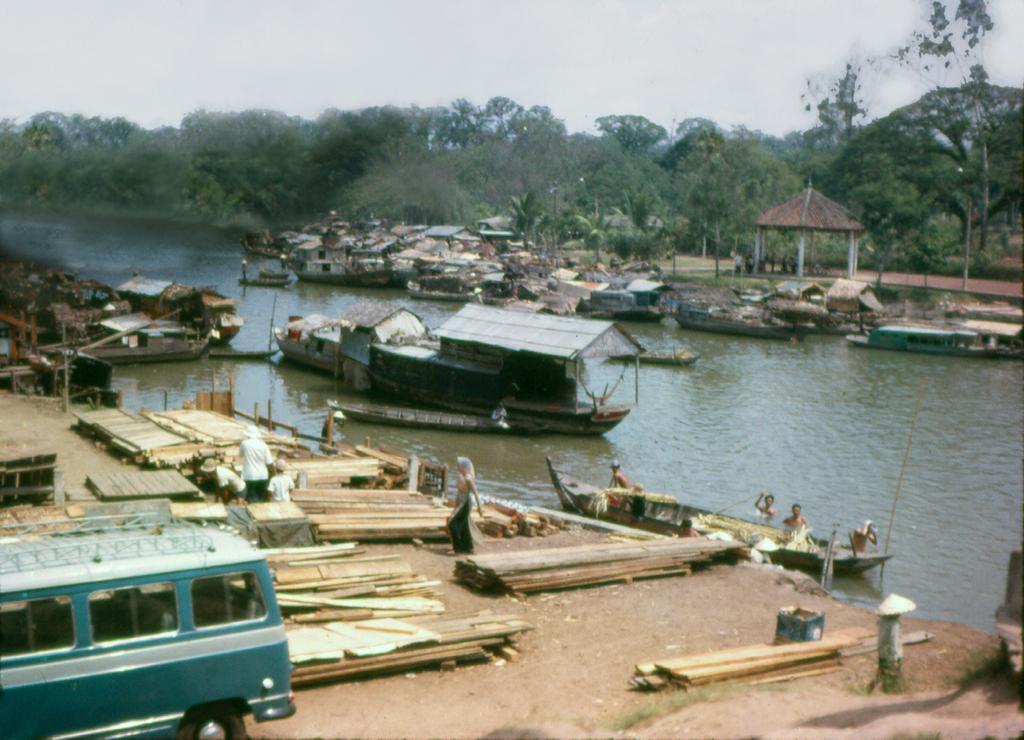In one or two sentences, can you explain what this image depicts? In this picture we can see a van, wooden planks, people and boats, in the background we can see water and trees. 